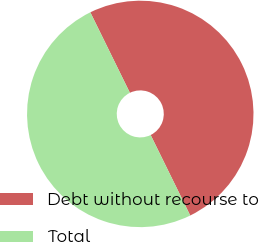<chart> <loc_0><loc_0><loc_500><loc_500><pie_chart><fcel>Debt without recourse to<fcel>Total<nl><fcel>50.0%<fcel>50.0%<nl></chart> 